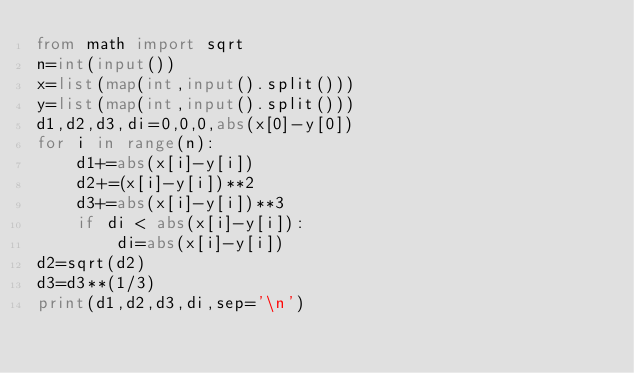<code> <loc_0><loc_0><loc_500><loc_500><_Python_>from math import sqrt
n=int(input())
x=list(map(int,input().split()))
y=list(map(int,input().split()))
d1,d2,d3,di=0,0,0,abs(x[0]-y[0])
for i in range(n):
    d1+=abs(x[i]-y[i])
    d2+=(x[i]-y[i])**2
    d3+=abs(x[i]-y[i])**3
    if di < abs(x[i]-y[i]):
        di=abs(x[i]-y[i])
d2=sqrt(d2)
d3=d3**(1/3)
print(d1,d2,d3,di,sep='\n')
</code> 